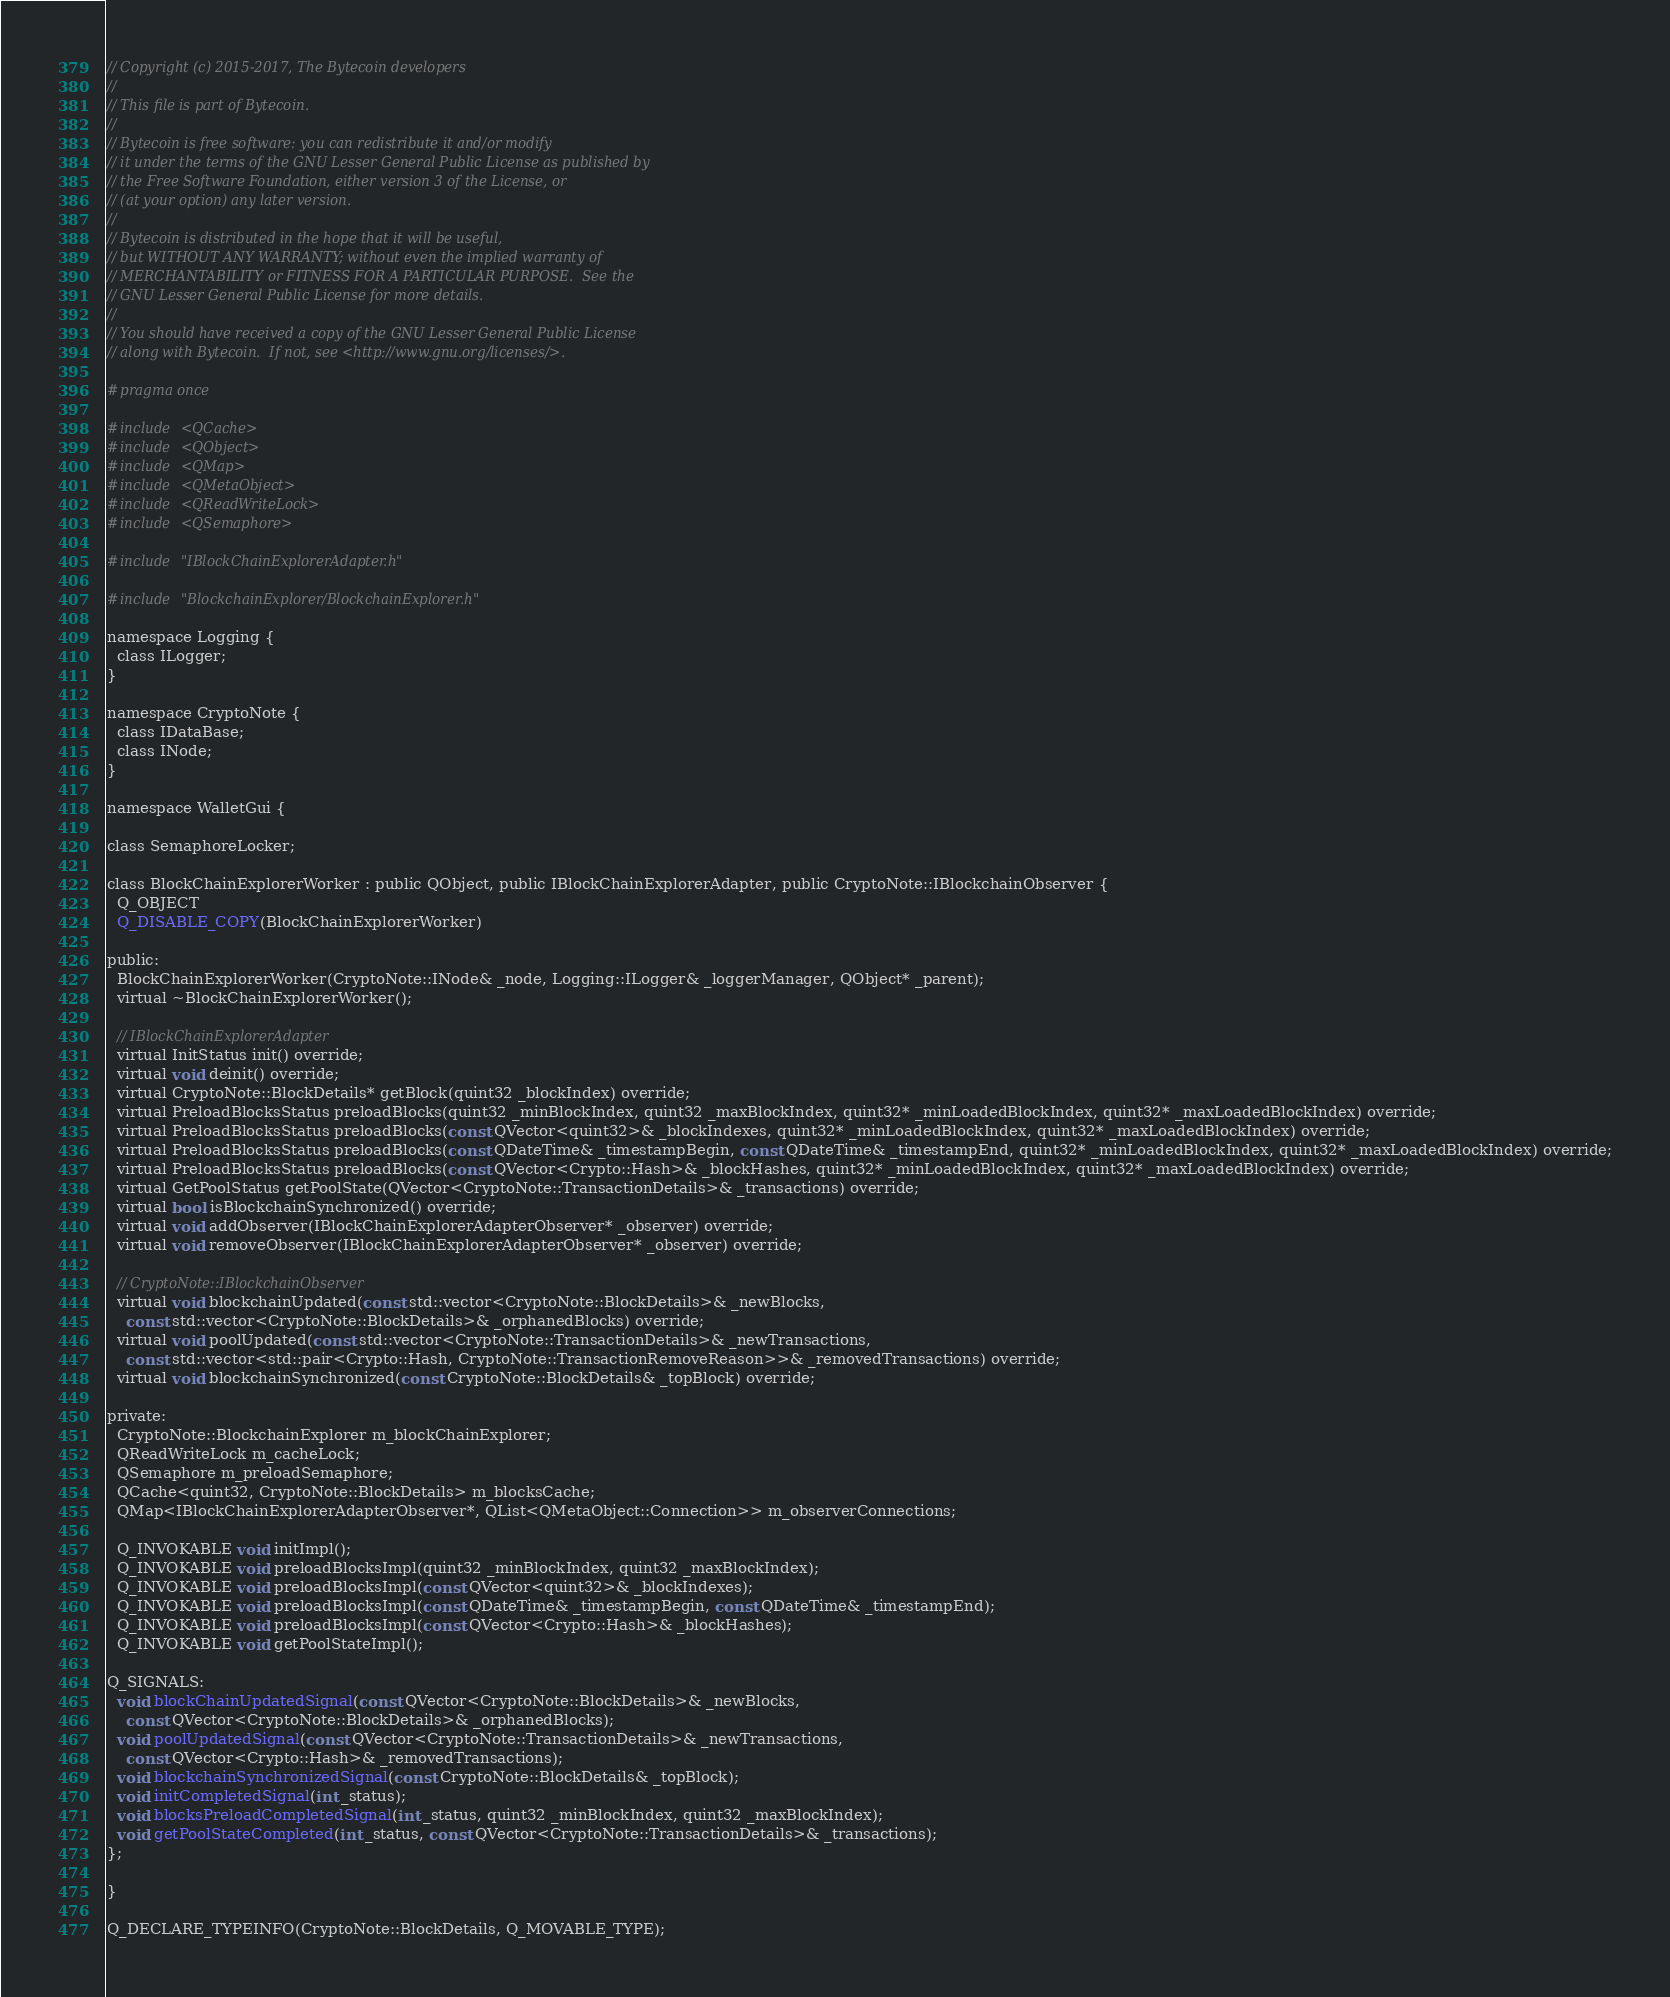<code> <loc_0><loc_0><loc_500><loc_500><_C_>// Copyright (c) 2015-2017, The Bytecoin developers
//
// This file is part of Bytecoin.
//
// Bytecoin is free software: you can redistribute it and/or modify
// it under the terms of the GNU Lesser General Public License as published by
// the Free Software Foundation, either version 3 of the License, or
// (at your option) any later version.
//
// Bytecoin is distributed in the hope that it will be useful,
// but WITHOUT ANY WARRANTY; without even the implied warranty of
// MERCHANTABILITY or FITNESS FOR A PARTICULAR PURPOSE.  See the
// GNU Lesser General Public License for more details.
//
// You should have received a copy of the GNU Lesser General Public License
// along with Bytecoin.  If not, see <http://www.gnu.org/licenses/>.

#pragma once

#include <QCache>
#include <QObject>
#include <QMap>
#include <QMetaObject>
#include <QReadWriteLock>
#include <QSemaphore>

#include "IBlockChainExplorerAdapter.h"

#include "BlockchainExplorer/BlockchainExplorer.h"

namespace Logging {
  class ILogger;
}

namespace CryptoNote {
  class IDataBase;
  class INode;
}

namespace WalletGui {

class SemaphoreLocker;

class BlockChainExplorerWorker : public QObject, public IBlockChainExplorerAdapter, public CryptoNote::IBlockchainObserver {
  Q_OBJECT
  Q_DISABLE_COPY(BlockChainExplorerWorker)

public:
  BlockChainExplorerWorker(CryptoNote::INode& _node, Logging::ILogger& _loggerManager, QObject* _parent);
  virtual ~BlockChainExplorerWorker();

  // IBlockChainExplorerAdapter
  virtual InitStatus init() override;
  virtual void deinit() override;
  virtual CryptoNote::BlockDetails* getBlock(quint32 _blockIndex) override;
  virtual PreloadBlocksStatus preloadBlocks(quint32 _minBlockIndex, quint32 _maxBlockIndex, quint32* _minLoadedBlockIndex, quint32* _maxLoadedBlockIndex) override;
  virtual PreloadBlocksStatus preloadBlocks(const QVector<quint32>& _blockIndexes, quint32* _minLoadedBlockIndex, quint32* _maxLoadedBlockIndex) override;
  virtual PreloadBlocksStatus preloadBlocks(const QDateTime& _timestampBegin, const QDateTime& _timestampEnd, quint32* _minLoadedBlockIndex, quint32* _maxLoadedBlockIndex) override;
  virtual PreloadBlocksStatus preloadBlocks(const QVector<Crypto::Hash>& _blockHashes, quint32* _minLoadedBlockIndex, quint32* _maxLoadedBlockIndex) override;
  virtual GetPoolStatus getPoolState(QVector<CryptoNote::TransactionDetails>& _transactions) override;
  virtual bool isBlockchainSynchronized() override;
  virtual void addObserver(IBlockChainExplorerAdapterObserver* _observer) override;
  virtual void removeObserver(IBlockChainExplorerAdapterObserver* _observer) override;

  // CryptoNote::IBlockchainObserver
  virtual void blockchainUpdated(const std::vector<CryptoNote::BlockDetails>& _newBlocks,
    const std::vector<CryptoNote::BlockDetails>& _orphanedBlocks) override;
  virtual void poolUpdated(const std::vector<CryptoNote::TransactionDetails>& _newTransactions,
    const std::vector<std::pair<Crypto::Hash, CryptoNote::TransactionRemoveReason>>& _removedTransactions) override;
  virtual void blockchainSynchronized(const CryptoNote::BlockDetails& _topBlock) override;

private:
  CryptoNote::BlockchainExplorer m_blockChainExplorer;
  QReadWriteLock m_cacheLock;
  QSemaphore m_preloadSemaphore;
  QCache<quint32, CryptoNote::BlockDetails> m_blocksCache;
  QMap<IBlockChainExplorerAdapterObserver*, QList<QMetaObject::Connection>> m_observerConnections;

  Q_INVOKABLE void initImpl();
  Q_INVOKABLE void preloadBlocksImpl(quint32 _minBlockIndex, quint32 _maxBlockIndex);
  Q_INVOKABLE void preloadBlocksImpl(const QVector<quint32>& _blockIndexes);
  Q_INVOKABLE void preloadBlocksImpl(const QDateTime& _timestampBegin, const QDateTime& _timestampEnd);
  Q_INVOKABLE void preloadBlocksImpl(const QVector<Crypto::Hash>& _blockHashes);
  Q_INVOKABLE void getPoolStateImpl();

Q_SIGNALS:
  void blockChainUpdatedSignal(const QVector<CryptoNote::BlockDetails>& _newBlocks,
    const QVector<CryptoNote::BlockDetails>& _orphanedBlocks);
  void poolUpdatedSignal(const QVector<CryptoNote::TransactionDetails>& _newTransactions,
    const QVector<Crypto::Hash>& _removedTransactions);
  void blockchainSynchronizedSignal(const CryptoNote::BlockDetails& _topBlock);
  void initCompletedSignal(int _status);
  void blocksPreloadCompletedSignal(int _status, quint32 _minBlockIndex, quint32 _maxBlockIndex);
  void getPoolStateCompleted(int _status, const QVector<CryptoNote::TransactionDetails>& _transactions);
};

}

Q_DECLARE_TYPEINFO(CryptoNote::BlockDetails, Q_MOVABLE_TYPE);
</code> 